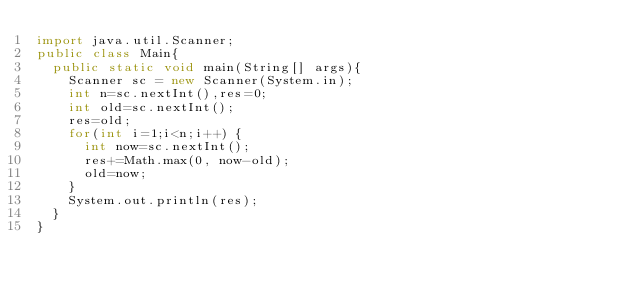Convert code to text. <code><loc_0><loc_0><loc_500><loc_500><_Java_>import java.util.Scanner;
public class Main{
  public static void main(String[] args){
    Scanner sc = new Scanner(System.in);
    int n=sc.nextInt(),res=0;
    int old=sc.nextInt();
    res=old;
    for(int i=1;i<n;i++) {
    	int now=sc.nextInt();
    	res+=Math.max(0, now-old);
    	old=now;
    }
    System.out.println(res);
  }
}
</code> 